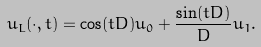Convert formula to latex. <formula><loc_0><loc_0><loc_500><loc_500>u _ { L } ( \cdot , t ) = \cos ( t D ) u _ { 0 } + \frac { \sin ( t D ) } { D } u _ { 1 } .</formula> 